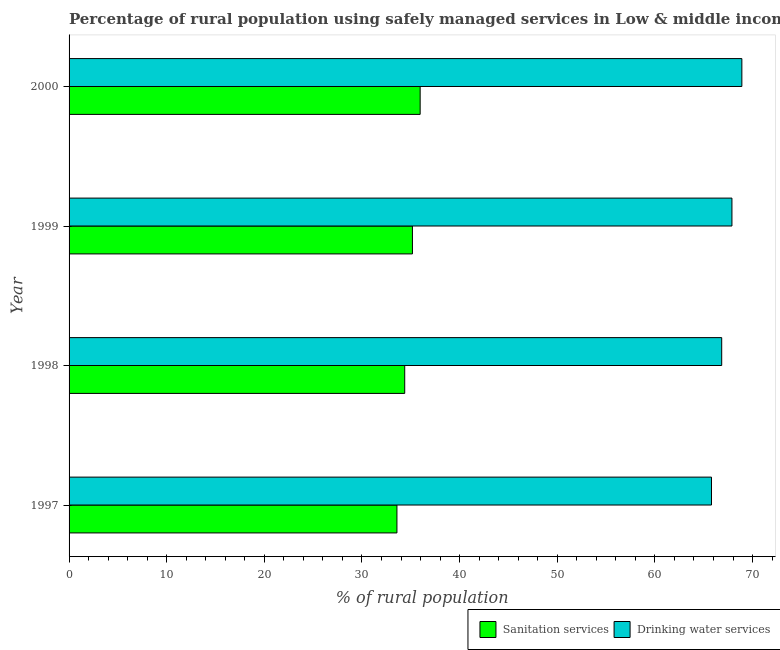How many different coloured bars are there?
Keep it short and to the point. 2. Are the number of bars per tick equal to the number of legend labels?
Offer a very short reply. Yes. Are the number of bars on each tick of the Y-axis equal?
Provide a succinct answer. Yes. How many bars are there on the 1st tick from the bottom?
Offer a terse response. 2. What is the percentage of rural population who used sanitation services in 1999?
Offer a terse response. 35.17. Across all years, what is the maximum percentage of rural population who used sanitation services?
Provide a short and direct response. 35.96. Across all years, what is the minimum percentage of rural population who used drinking water services?
Provide a short and direct response. 65.8. In which year was the percentage of rural population who used sanitation services minimum?
Your response must be concise. 1997. What is the total percentage of rural population who used drinking water services in the graph?
Provide a short and direct response. 269.43. What is the difference between the percentage of rural population who used sanitation services in 1998 and that in 1999?
Provide a short and direct response. -0.79. What is the difference between the percentage of rural population who used sanitation services in 1999 and the percentage of rural population who used drinking water services in 2000?
Your answer should be very brief. -33.74. What is the average percentage of rural population who used drinking water services per year?
Make the answer very short. 67.36. In the year 2000, what is the difference between the percentage of rural population who used drinking water services and percentage of rural population who used sanitation services?
Offer a very short reply. 32.95. Is the percentage of rural population who used sanitation services in 1997 less than that in 1999?
Provide a succinct answer. Yes. Is the difference between the percentage of rural population who used drinking water services in 1997 and 2000 greater than the difference between the percentage of rural population who used sanitation services in 1997 and 2000?
Provide a succinct answer. No. What is the difference between the highest and the second highest percentage of rural population who used sanitation services?
Keep it short and to the point. 0.79. What is the difference between the highest and the lowest percentage of rural population who used drinking water services?
Keep it short and to the point. 3.11. In how many years, is the percentage of rural population who used sanitation services greater than the average percentage of rural population who used sanitation services taken over all years?
Keep it short and to the point. 2. What does the 2nd bar from the top in 1999 represents?
Your answer should be very brief. Sanitation services. What does the 2nd bar from the bottom in 2000 represents?
Provide a succinct answer. Drinking water services. How many bars are there?
Make the answer very short. 8. How many years are there in the graph?
Your answer should be compact. 4. Does the graph contain any zero values?
Your response must be concise. No. How many legend labels are there?
Ensure brevity in your answer.  2. What is the title of the graph?
Make the answer very short. Percentage of rural population using safely managed services in Low & middle income. What is the label or title of the X-axis?
Provide a short and direct response. % of rural population. What is the label or title of the Y-axis?
Your answer should be very brief. Year. What is the % of rural population of Sanitation services in 1997?
Offer a very short reply. 33.58. What is the % of rural population in Drinking water services in 1997?
Keep it short and to the point. 65.8. What is the % of rural population of Sanitation services in 1998?
Your answer should be compact. 34.38. What is the % of rural population in Drinking water services in 1998?
Provide a succinct answer. 66.84. What is the % of rural population in Sanitation services in 1999?
Your answer should be very brief. 35.17. What is the % of rural population in Drinking water services in 1999?
Provide a succinct answer. 67.89. What is the % of rural population in Sanitation services in 2000?
Ensure brevity in your answer.  35.96. What is the % of rural population of Drinking water services in 2000?
Your answer should be compact. 68.91. Across all years, what is the maximum % of rural population of Sanitation services?
Make the answer very short. 35.96. Across all years, what is the maximum % of rural population in Drinking water services?
Make the answer very short. 68.91. Across all years, what is the minimum % of rural population in Sanitation services?
Provide a succinct answer. 33.58. Across all years, what is the minimum % of rural population of Drinking water services?
Offer a terse response. 65.8. What is the total % of rural population in Sanitation services in the graph?
Give a very brief answer. 139.08. What is the total % of rural population of Drinking water services in the graph?
Keep it short and to the point. 269.43. What is the difference between the % of rural population of Sanitation services in 1997 and that in 1998?
Offer a terse response. -0.8. What is the difference between the % of rural population in Drinking water services in 1997 and that in 1998?
Give a very brief answer. -1.05. What is the difference between the % of rural population of Sanitation services in 1997 and that in 1999?
Keep it short and to the point. -1.59. What is the difference between the % of rural population of Drinking water services in 1997 and that in 1999?
Ensure brevity in your answer.  -2.09. What is the difference between the % of rural population in Sanitation services in 1997 and that in 2000?
Your response must be concise. -2.38. What is the difference between the % of rural population of Drinking water services in 1997 and that in 2000?
Offer a very short reply. -3.11. What is the difference between the % of rural population of Sanitation services in 1998 and that in 1999?
Keep it short and to the point. -0.79. What is the difference between the % of rural population of Drinking water services in 1998 and that in 1999?
Ensure brevity in your answer.  -1.05. What is the difference between the % of rural population in Sanitation services in 1998 and that in 2000?
Your answer should be very brief. -1.58. What is the difference between the % of rural population of Drinking water services in 1998 and that in 2000?
Offer a very short reply. -2.06. What is the difference between the % of rural population in Sanitation services in 1999 and that in 2000?
Keep it short and to the point. -0.79. What is the difference between the % of rural population in Drinking water services in 1999 and that in 2000?
Your response must be concise. -1.02. What is the difference between the % of rural population of Sanitation services in 1997 and the % of rural population of Drinking water services in 1998?
Provide a short and direct response. -33.26. What is the difference between the % of rural population of Sanitation services in 1997 and the % of rural population of Drinking water services in 1999?
Ensure brevity in your answer.  -34.31. What is the difference between the % of rural population of Sanitation services in 1997 and the % of rural population of Drinking water services in 2000?
Ensure brevity in your answer.  -35.33. What is the difference between the % of rural population in Sanitation services in 1998 and the % of rural population in Drinking water services in 1999?
Offer a terse response. -33.51. What is the difference between the % of rural population in Sanitation services in 1998 and the % of rural population in Drinking water services in 2000?
Offer a very short reply. -34.53. What is the difference between the % of rural population of Sanitation services in 1999 and the % of rural population of Drinking water services in 2000?
Provide a short and direct response. -33.74. What is the average % of rural population of Sanitation services per year?
Give a very brief answer. 34.77. What is the average % of rural population in Drinking water services per year?
Ensure brevity in your answer.  67.36. In the year 1997, what is the difference between the % of rural population in Sanitation services and % of rural population in Drinking water services?
Give a very brief answer. -32.22. In the year 1998, what is the difference between the % of rural population in Sanitation services and % of rural population in Drinking water services?
Keep it short and to the point. -32.47. In the year 1999, what is the difference between the % of rural population of Sanitation services and % of rural population of Drinking water services?
Keep it short and to the point. -32.72. In the year 2000, what is the difference between the % of rural population in Sanitation services and % of rural population in Drinking water services?
Ensure brevity in your answer.  -32.95. What is the ratio of the % of rural population in Sanitation services in 1997 to that in 1998?
Keep it short and to the point. 0.98. What is the ratio of the % of rural population in Drinking water services in 1997 to that in 1998?
Your answer should be very brief. 0.98. What is the ratio of the % of rural population in Sanitation services in 1997 to that in 1999?
Your answer should be compact. 0.95. What is the ratio of the % of rural population of Drinking water services in 1997 to that in 1999?
Provide a short and direct response. 0.97. What is the ratio of the % of rural population of Sanitation services in 1997 to that in 2000?
Your answer should be compact. 0.93. What is the ratio of the % of rural population of Drinking water services in 1997 to that in 2000?
Keep it short and to the point. 0.95. What is the ratio of the % of rural population in Sanitation services in 1998 to that in 1999?
Your response must be concise. 0.98. What is the ratio of the % of rural population of Drinking water services in 1998 to that in 1999?
Provide a short and direct response. 0.98. What is the ratio of the % of rural population in Sanitation services in 1998 to that in 2000?
Provide a succinct answer. 0.96. What is the ratio of the % of rural population of Drinking water services in 1998 to that in 2000?
Provide a succinct answer. 0.97. What is the ratio of the % of rural population in Sanitation services in 1999 to that in 2000?
Ensure brevity in your answer.  0.98. What is the ratio of the % of rural population in Drinking water services in 1999 to that in 2000?
Your answer should be compact. 0.99. What is the difference between the highest and the second highest % of rural population in Sanitation services?
Offer a very short reply. 0.79. What is the difference between the highest and the second highest % of rural population in Drinking water services?
Offer a very short reply. 1.02. What is the difference between the highest and the lowest % of rural population of Sanitation services?
Your answer should be very brief. 2.38. What is the difference between the highest and the lowest % of rural population of Drinking water services?
Your answer should be compact. 3.11. 